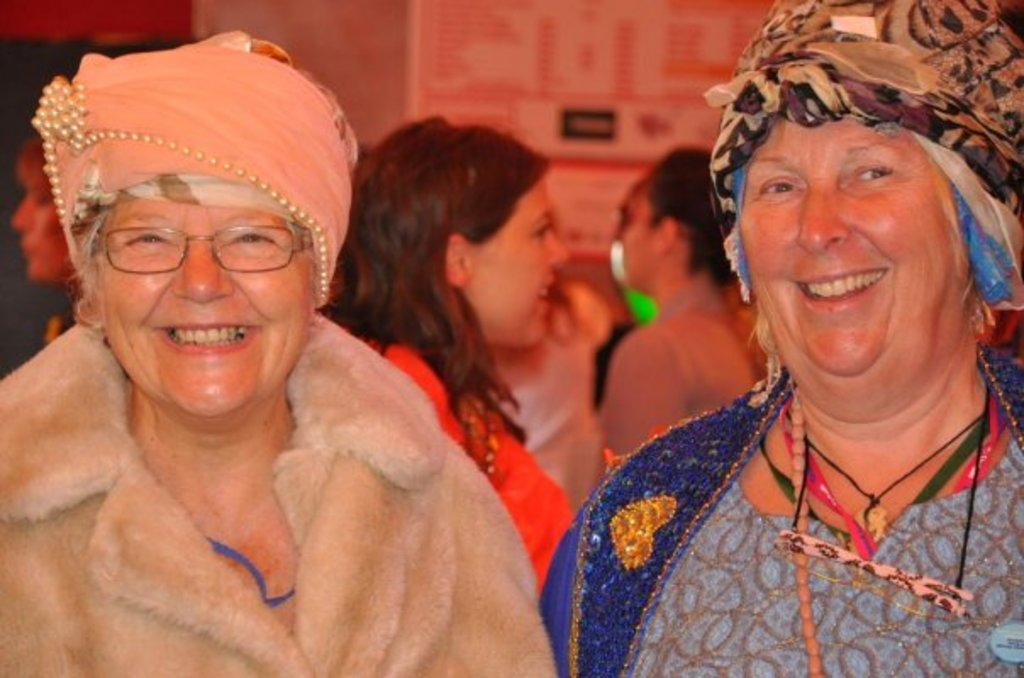How many women are present in the image? There are two women in the image. What is the facial expression of the women? Both women are smiling. Can you describe the background of the image? There are people and objects on the wall in the background of the image. What type of snakes can be seen slithering on the wall in the image? There are no snakes present in the image; the objects on the wall are not snakes. What boundary is visible in the image? There is no boundary visible in the image. 